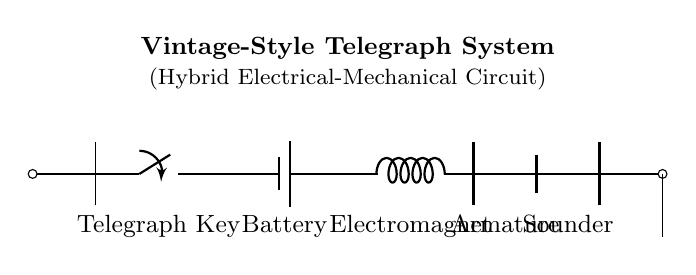What is the primary function of the telegraph key? The telegraph key serves as a mechanical switch to control the flow of current in the circuit. When pressed, it connects the circuit, allowing current to flow and activating the electromagnet.
Answer: mechanical switch What component generates the magnetic field in the circuit? The component that generates the magnetic field is the electromagnet. When current flows through it, it creates a magnetic field that attracts the armature.
Answer: electromagnet How does the armature affect the sounder? The armature moves in response to the electromagnetic field created by the electromagnet. As it moves, it mechanically strikes the sounder, producing sound.
Answer: creates sound What type of battery is used in this telegraph system? The circuit diagram specifies a battery, which is a direct current power source typically used in telegraph systems. The exact type isn't given, but it is essential for supplying electrical energy.
Answer: battery What is the role of the ground connection in this circuit? The ground connection provides a reference point for the electrical circuit, ensuring that excess current has a safe path to discharge and preventing short circuits.
Answer: reference point How do mechanical components integrate with electrical elements in this circuit? The circuit demonstrates a hybrid system where mechanical components like the telegraph key and armature interact with electrical components such as the battery and electromagnet. The mechanical components actuate based on electrical signals, completing the telegraph function.
Answer: hybrid system What is the potential difference supplied by the battery in this circuit? While the circuit doesn't specify an exact voltage in the diagram, a typical battery used in telegraph systems is often around 6 to 12 volts, suitable for driving the electromagnet and actuating the sounder effectively.
Answer: 6 to 12 volts 